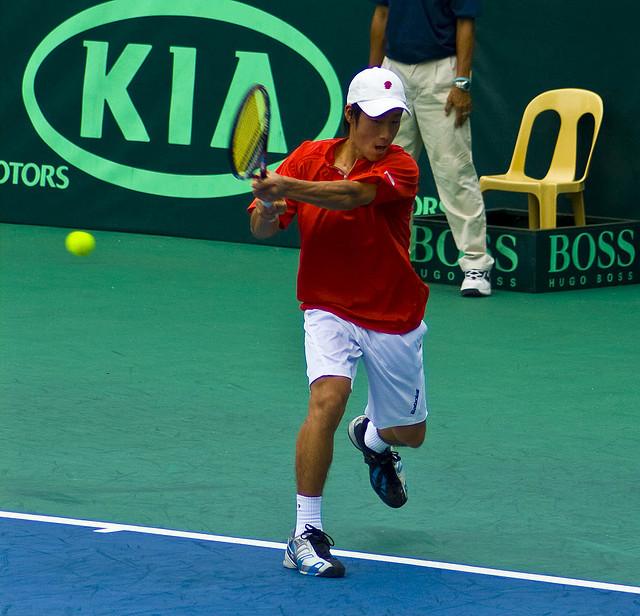Are his shirt and hat the same color?
Keep it brief. No. What is the company on the wall?
Short answer required. Kia. What letters can you see on the banner?
Short answer required. Kia. What car brand is advertised?
Concise answer only. Kia. Is there a yellow chair in the background?
Concise answer only. Yes. What car company is on the sign?
Short answer required. Kia. What color is the man's shirt?
Short answer required. Red. Do the player's shorts and hat match?
Keep it brief. Yes. 